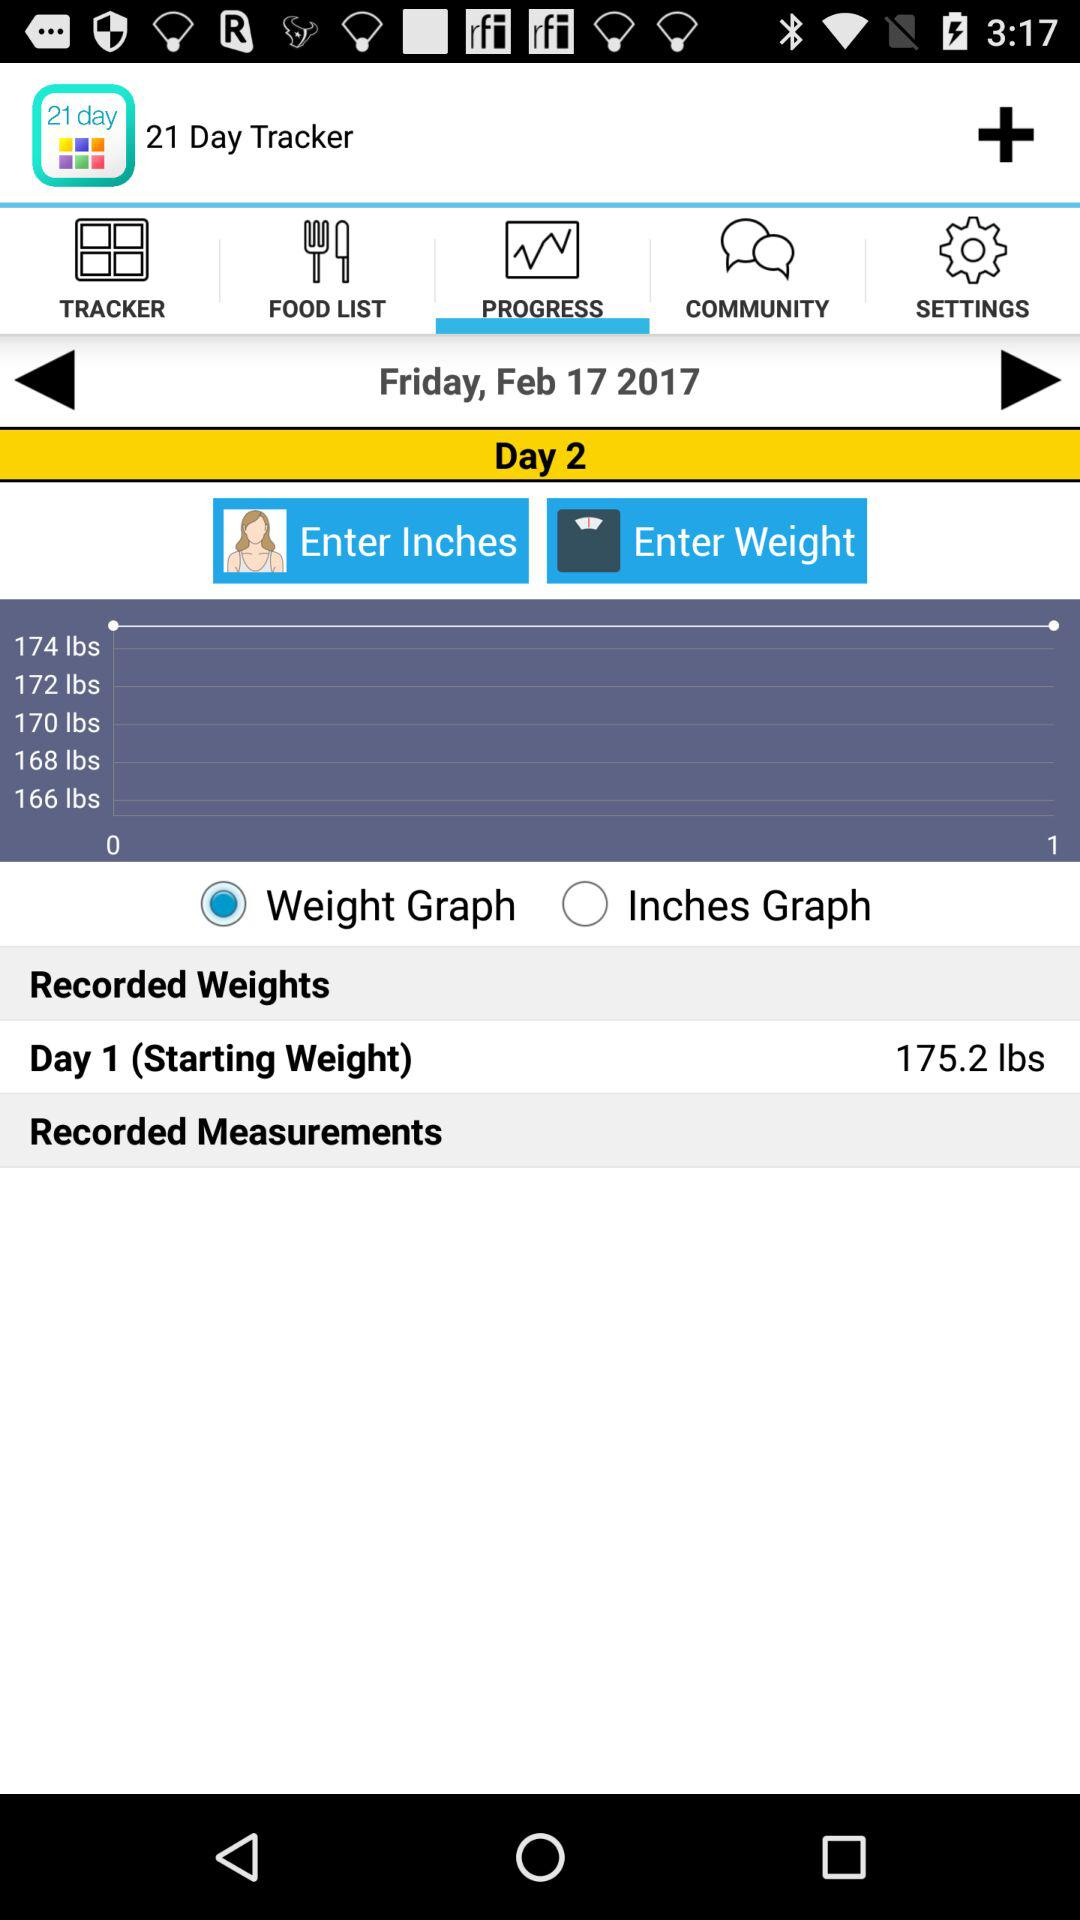What is the name of the application? The name of the application is "21 Day Tracker". 